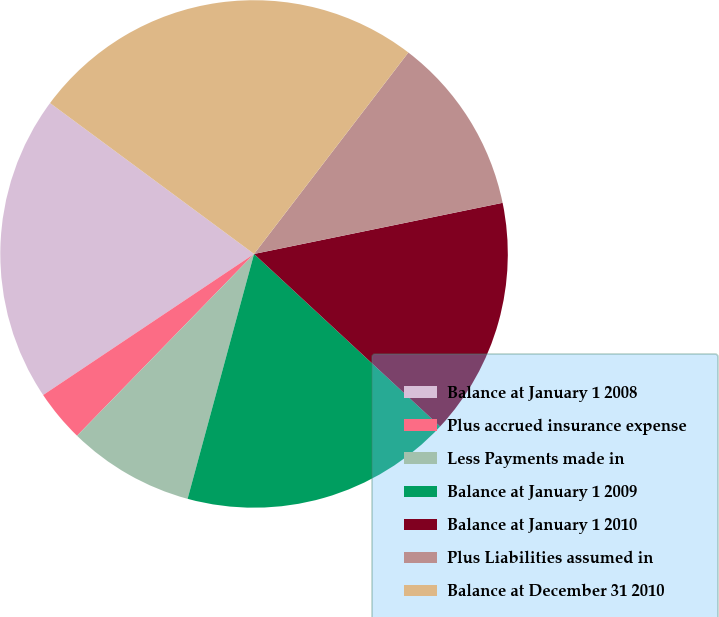Convert chart to OTSL. <chart><loc_0><loc_0><loc_500><loc_500><pie_chart><fcel>Balance at January 1 2008<fcel>Plus accrued insurance expense<fcel>Less Payments made in<fcel>Balance at January 1 2009<fcel>Balance at January 1 2010<fcel>Plus Liabilities assumed in<fcel>Balance at December 31 2010<nl><fcel>19.52%<fcel>3.33%<fcel>8.07%<fcel>17.32%<fcel>15.13%<fcel>11.37%<fcel>25.27%<nl></chart> 